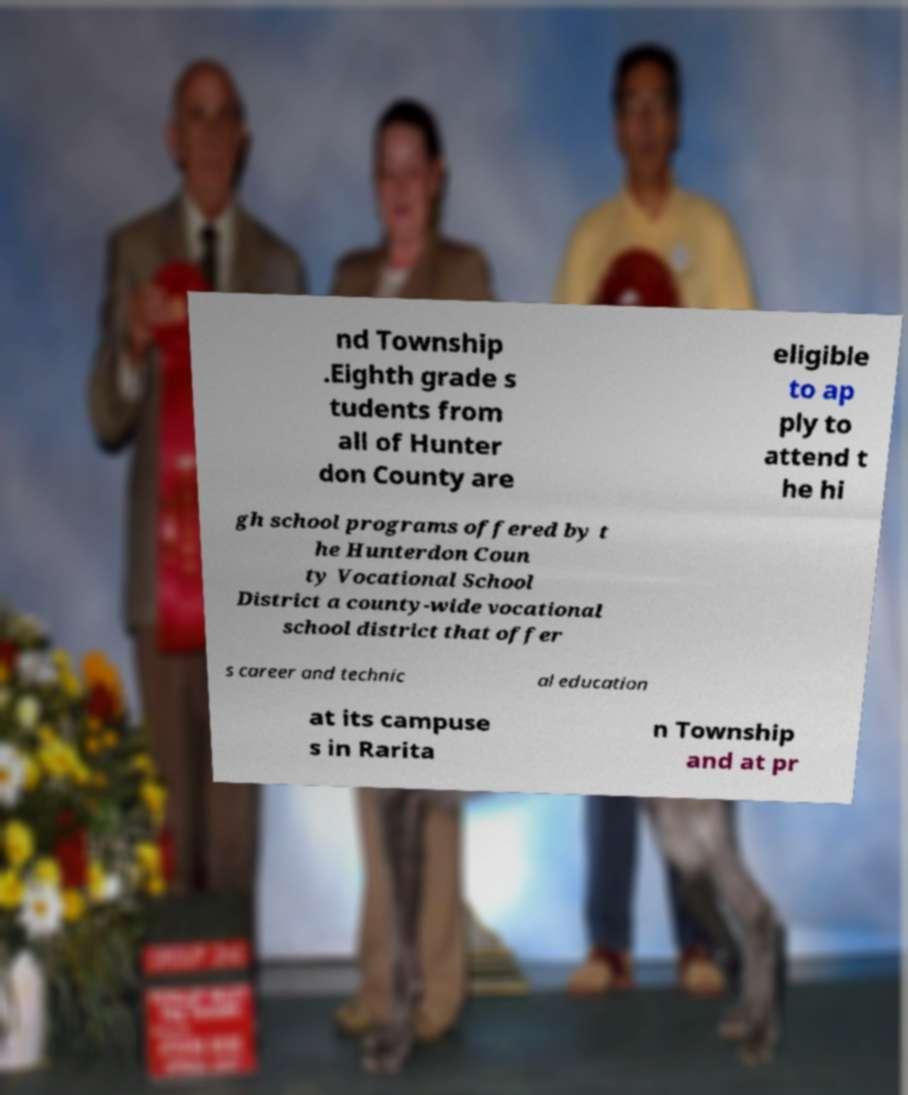Please read and relay the text visible in this image. What does it say? nd Township .Eighth grade s tudents from all of Hunter don County are eligible to ap ply to attend t he hi gh school programs offered by t he Hunterdon Coun ty Vocational School District a county-wide vocational school district that offer s career and technic al education at its campuse s in Rarita n Township and at pr 